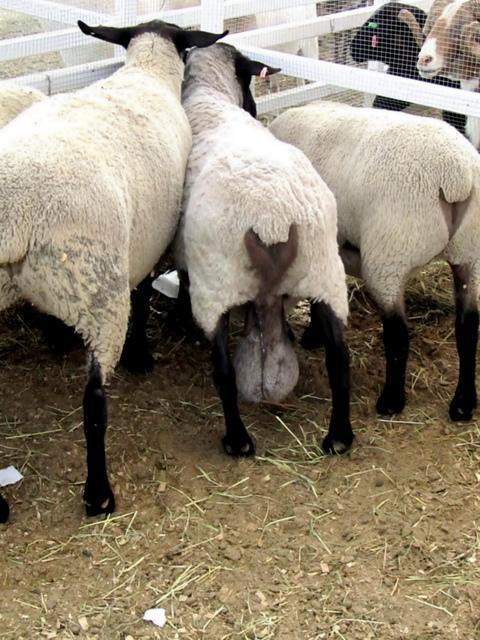How many animals are there?
Give a very brief answer. 6. How many sheep are there?
Give a very brief answer. 6. How many zebras are there?
Give a very brief answer. 0. 